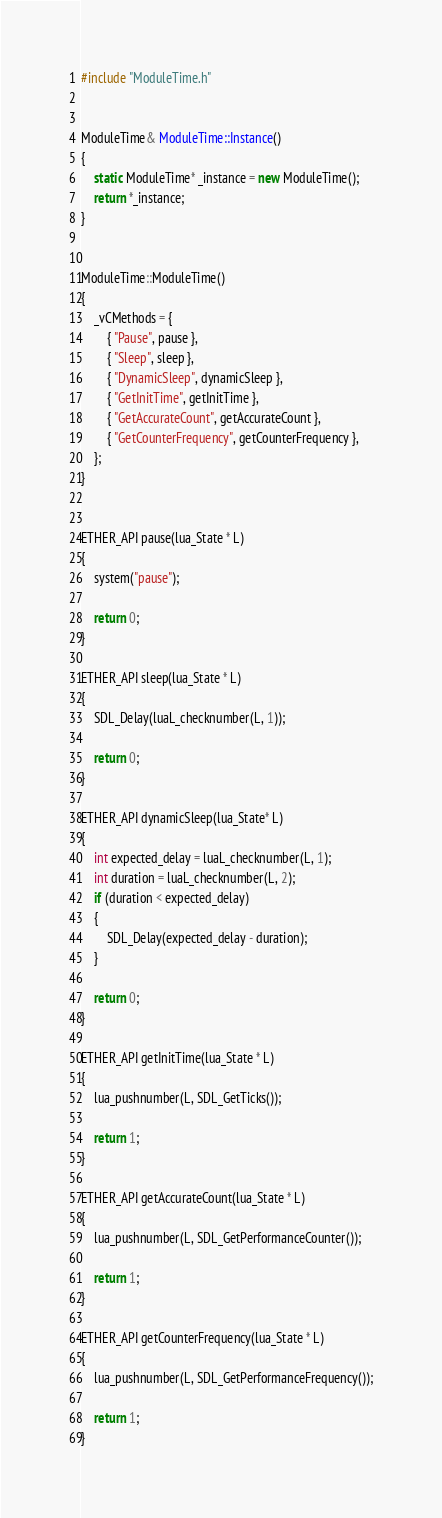<code> <loc_0><loc_0><loc_500><loc_500><_C++_>#include "ModuleTime.h"


ModuleTime& ModuleTime::Instance()
{
	static ModuleTime* _instance = new ModuleTime();
	return *_instance;
}


ModuleTime::ModuleTime()
{
	_vCMethods = {
		{ "Pause", pause },
		{ "Sleep", sleep },
		{ "DynamicSleep", dynamicSleep },
		{ "GetInitTime", getInitTime },
		{ "GetAccurateCount", getAccurateCount },
		{ "GetCounterFrequency", getCounterFrequency },
	};
}


ETHER_API pause(lua_State * L)
{
	system("pause");

	return 0;
}

ETHER_API sleep(lua_State * L)
{
	SDL_Delay(luaL_checknumber(L, 1));

	return 0;
}

ETHER_API dynamicSleep(lua_State* L)
{
	int expected_delay = luaL_checknumber(L, 1);
	int duration = luaL_checknumber(L, 2);
	if (duration < expected_delay)
	{
		SDL_Delay(expected_delay - duration);
	}

	return 0;
}

ETHER_API getInitTime(lua_State * L)
{
	lua_pushnumber(L, SDL_GetTicks());

	return 1;
}

ETHER_API getAccurateCount(lua_State * L)
{
	lua_pushnumber(L, SDL_GetPerformanceCounter());

	return 1;
}

ETHER_API getCounterFrequency(lua_State * L)
{
	lua_pushnumber(L, SDL_GetPerformanceFrequency());

	return 1;
}</code> 